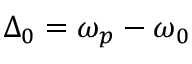<formula> <loc_0><loc_0><loc_500><loc_500>\Delta _ { 0 } = \omega _ { p } - \omega _ { 0 }</formula> 